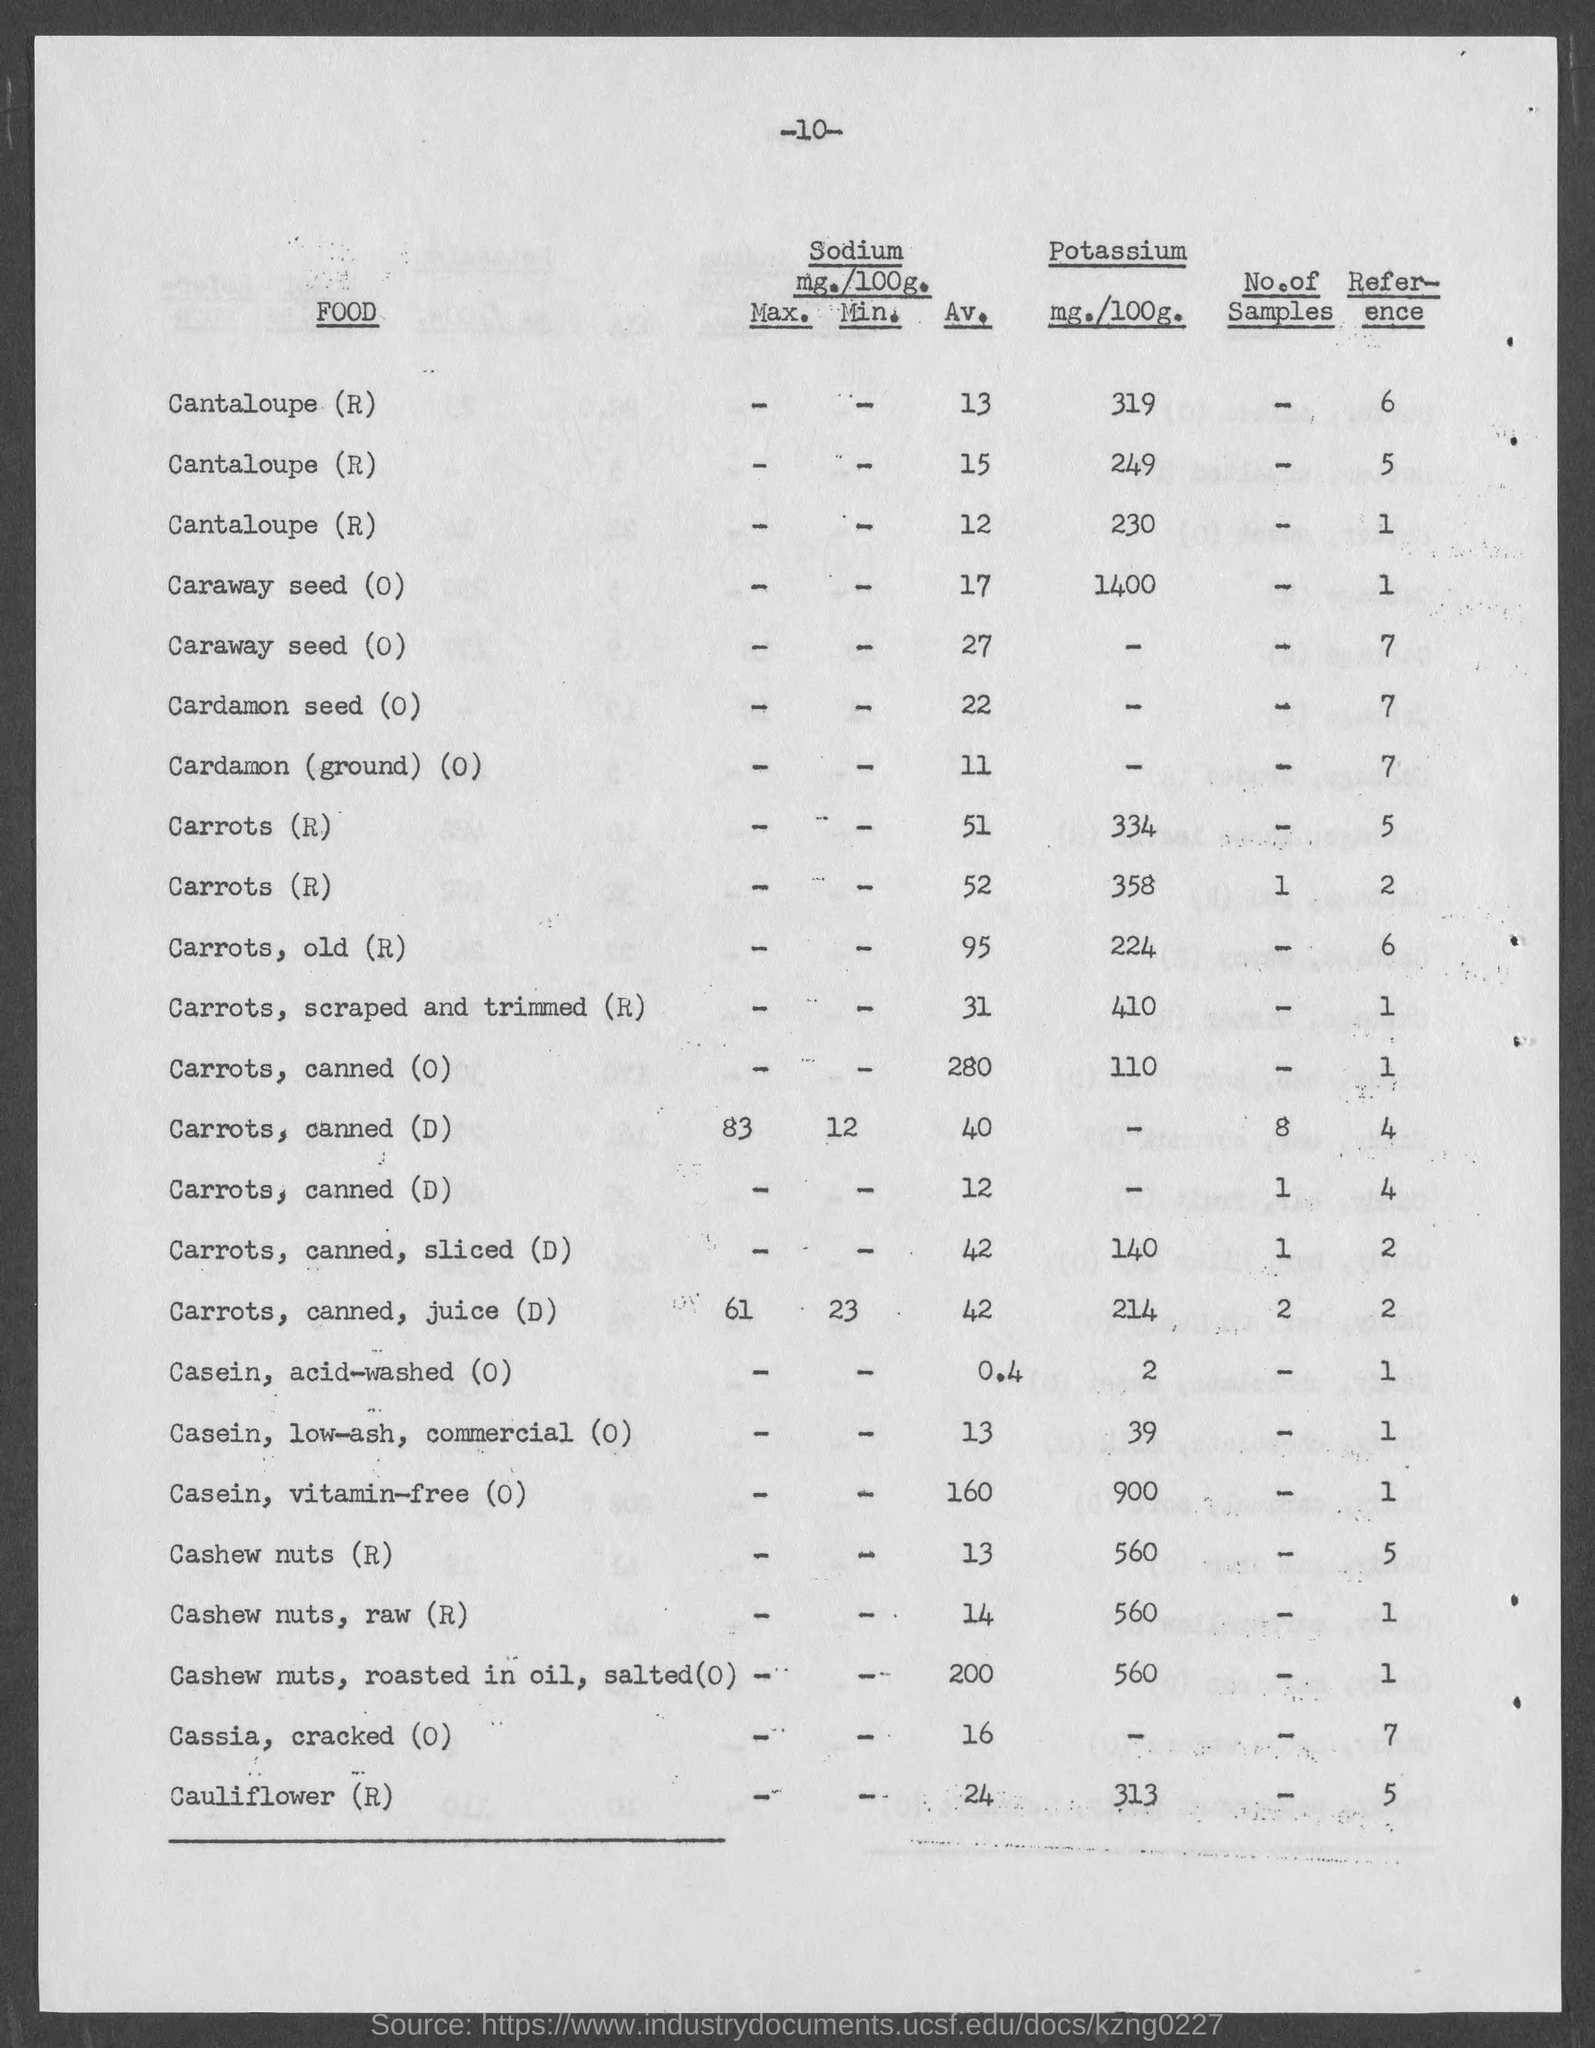What is the number at top of the page ?
Offer a very short reply. -10-. What is the amount of potassium mg./100g.  for carrots, old (r)?
Keep it short and to the point. 224. What is the amount of potassium mg./100g.  for carrots,scraped, trimmed (r)?
Provide a short and direct response. 410. What is the amount of potassium mg./100g.  for cauliflower (r)?
Give a very brief answer. 313. What is the amount of potassium mg./100g.  for cashew nuts (r)?
Your answer should be very brief. 560. What is the amount of potassium mg./100g.  for cashew nuts, raw(r)?
Offer a very short reply. 560. What is the amount of potassium mg./100g.  for cashew nuts. roasted in oil, salted (o)?
Offer a terse response. 560. What is the amount of potassium mg./100g.  for casein, acid-washed (o)?
Give a very brief answer. 2. What is the amount of potassium mg./100g.  for casein, low-ash, commercial (o)?
Your answer should be compact. 39. What is the amount of potassium mg./100g.  for casein, vitamin-free (o)?
Keep it short and to the point. 900. 